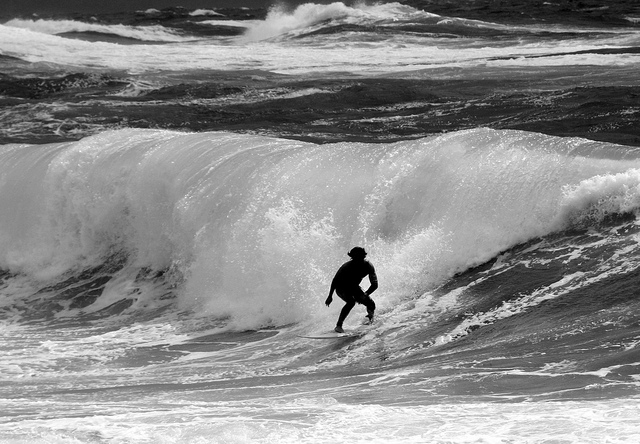Could you estimate the weather conditions based on the sea state? The rough sea, with its churning waves and spray, suggests windy conditions and possibly an approaching weather front, indicating challenging surfing conditions. 